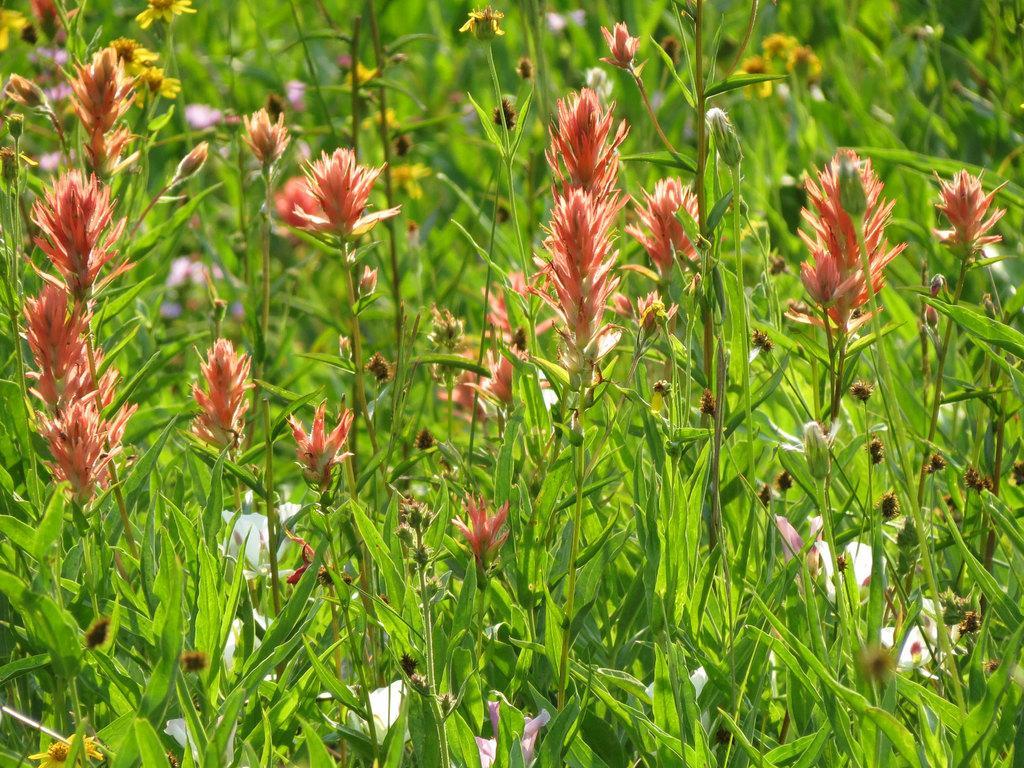Please provide a concise description of this image. The picture consists of plants and flowers. The background is blurred. In the background there is greenery. 